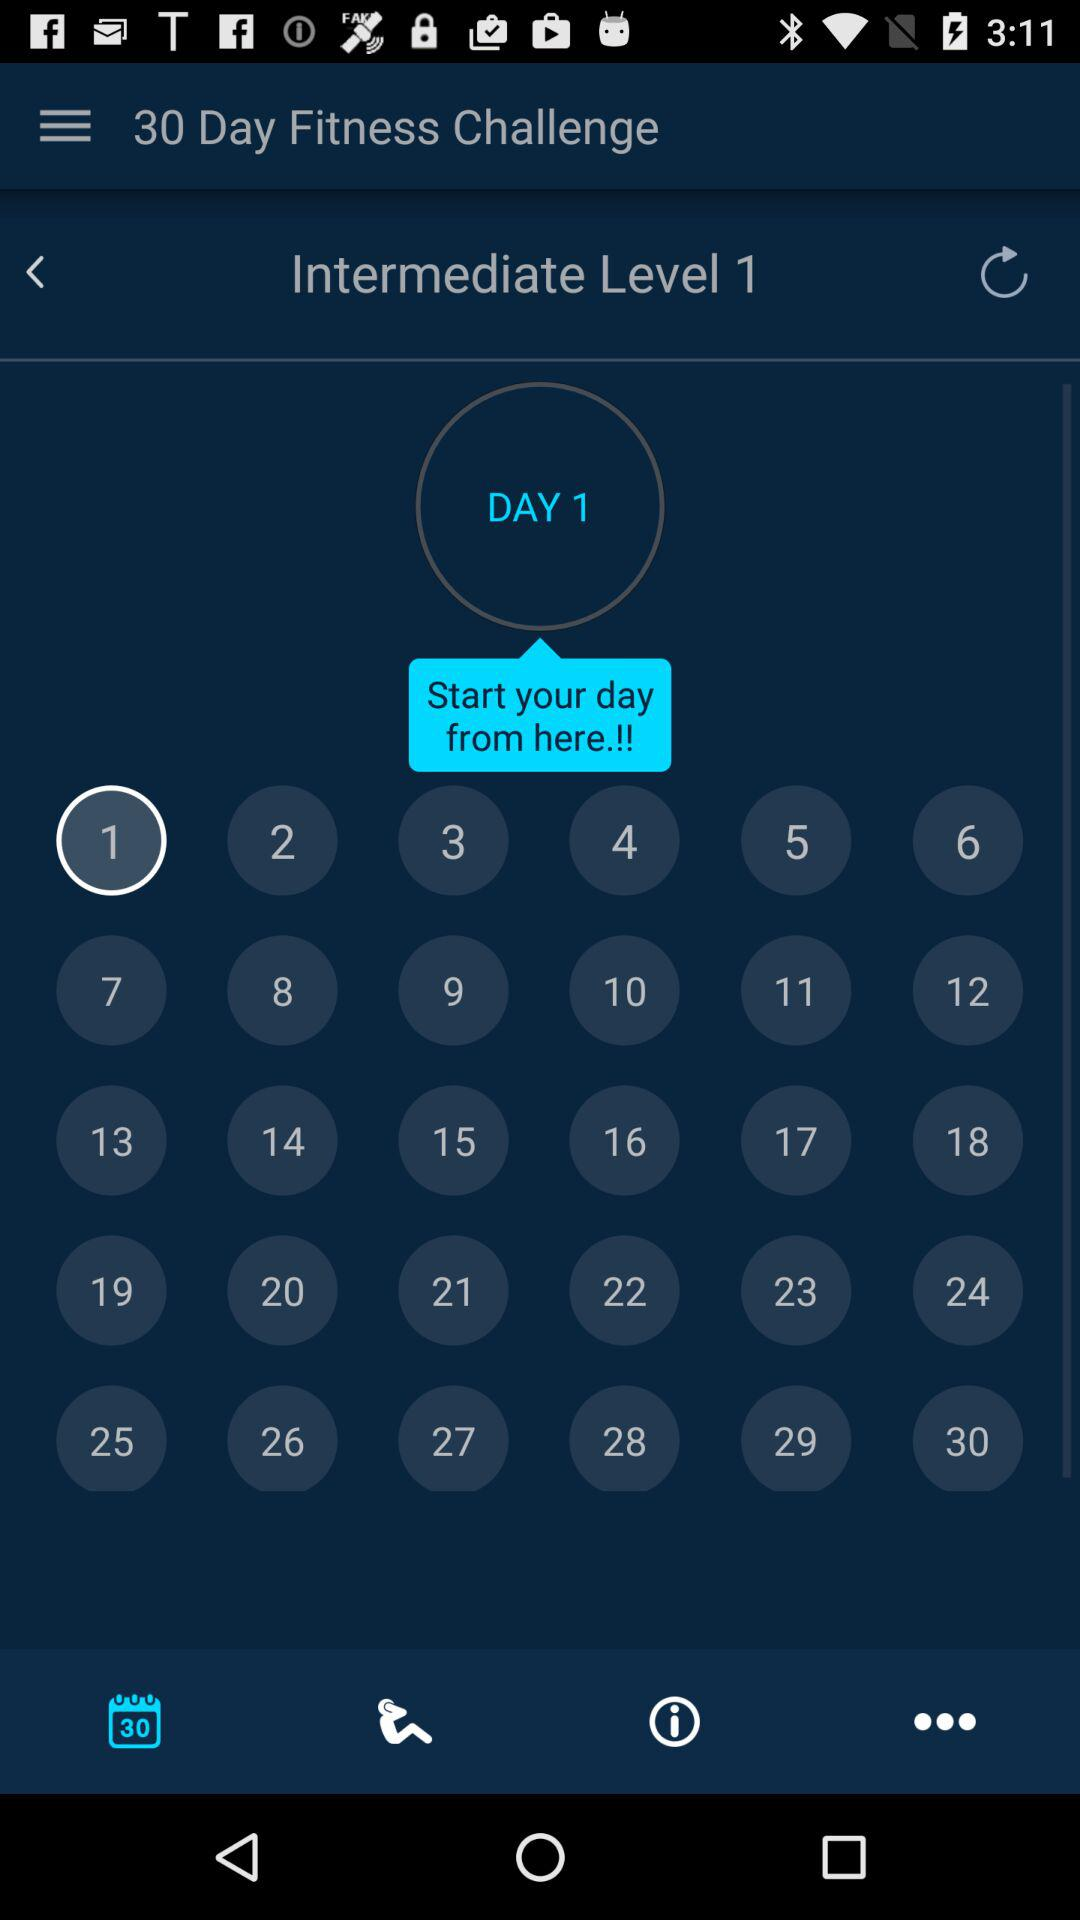What is the level of the challenge?
Answer the question using a single word or phrase. Intermediate 